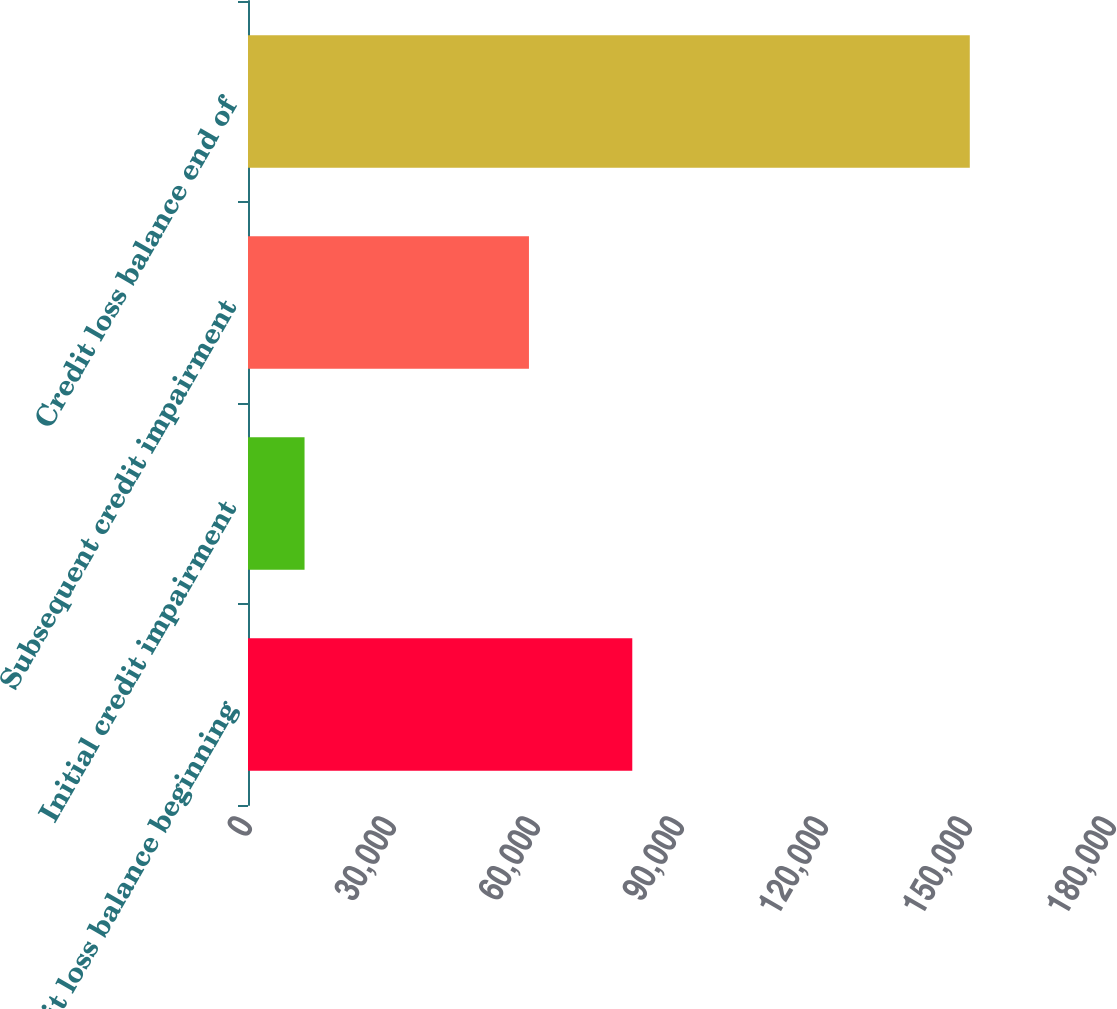Convert chart to OTSL. <chart><loc_0><loc_0><loc_500><loc_500><bar_chart><fcel>Credit loss balance beginning<fcel>Initial credit impairment<fcel>Subsequent credit impairment<fcel>Credit loss balance end of<nl><fcel>80060<fcel>11780<fcel>58532<fcel>150372<nl></chart> 